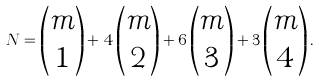<formula> <loc_0><loc_0><loc_500><loc_500>N = \begin{pmatrix} m \\ 1 \end{pmatrix} + 4 \begin{pmatrix} m \\ 2 \end{pmatrix} + 6 \begin{pmatrix} m \\ 3 \end{pmatrix} + 3 \begin{pmatrix} m \\ 4 \end{pmatrix} .</formula> 